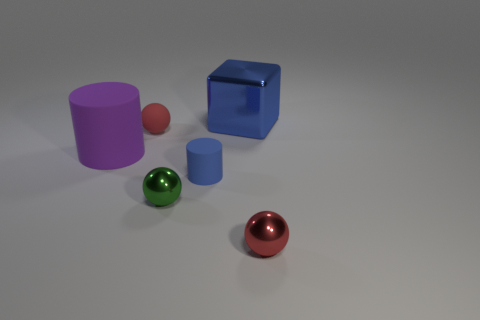Is the tiny matte cylinder the same color as the large matte object?
Keep it short and to the point. No. What number of metallic things are tiny cylinders or big blue things?
Provide a succinct answer. 1. How many big red objects are there?
Your response must be concise. 0. Do the red ball that is behind the small red metallic object and the tiny ball on the right side of the small green thing have the same material?
Offer a very short reply. No. The matte thing that is the same shape as the green shiny object is what color?
Offer a terse response. Red. There is a large blue thing behind the tiny red thing that is in front of the tiny green metal sphere; what is its material?
Offer a very short reply. Metal. There is a tiny thing behind the big purple matte cylinder; is it the same shape as the tiny red object in front of the green thing?
Give a very brief answer. Yes. What size is the thing that is both behind the big matte cylinder and right of the rubber ball?
Your answer should be very brief. Large. How many other objects are the same color as the small cylinder?
Keep it short and to the point. 1. Is the number of big rubber cylinders the same as the number of yellow rubber balls?
Provide a succinct answer. No. 